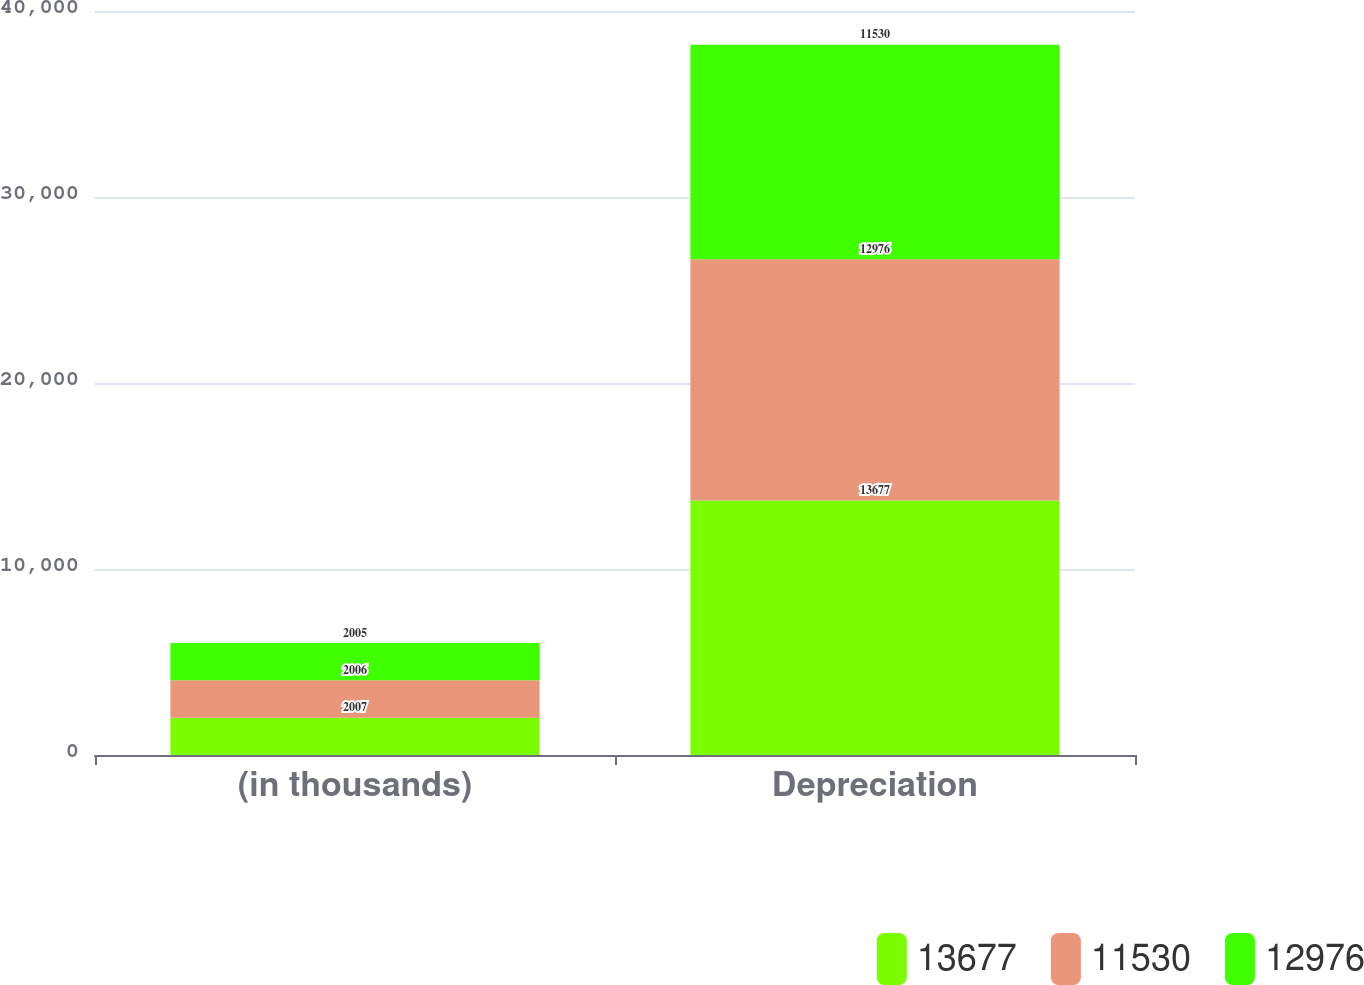Convert chart to OTSL. <chart><loc_0><loc_0><loc_500><loc_500><stacked_bar_chart><ecel><fcel>(in thousands)<fcel>Depreciation<nl><fcel>13677<fcel>2007<fcel>13677<nl><fcel>11530<fcel>2006<fcel>12976<nl><fcel>12976<fcel>2005<fcel>11530<nl></chart> 